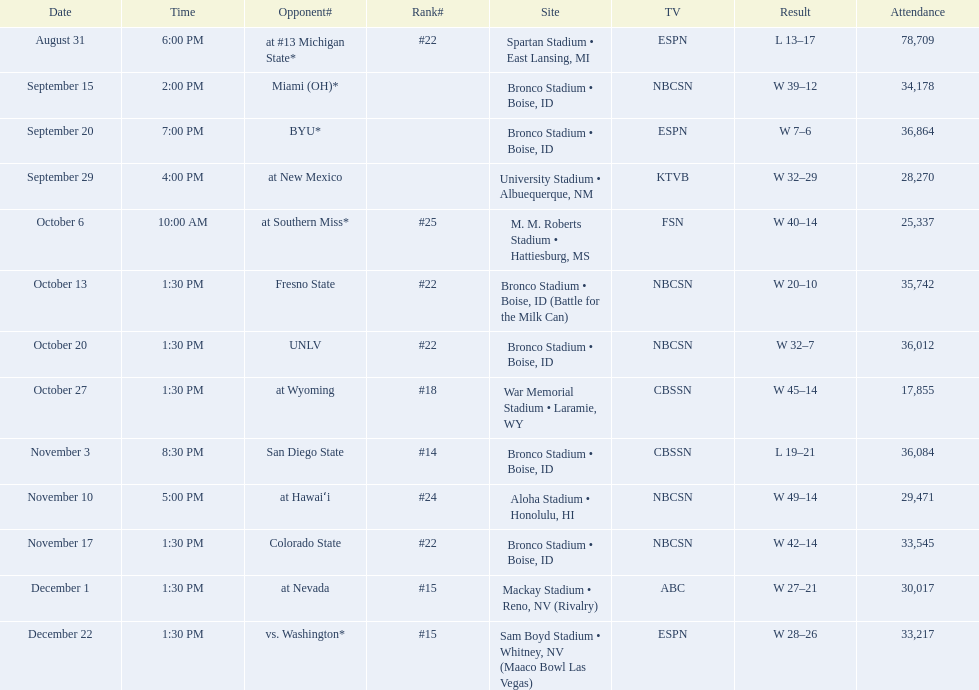Who were all the opponents for boise state? At #13 michigan state*, miami (oh)*, byu*, at new mexico, at southern miss*, fresno state, unlv, at wyoming, san diego state, at hawaiʻi, colorado state, at nevada, vs. washington*. Which opponents were ranked? At #13 michigan state*, #22, at southern miss*, #25, fresno state, #22, unlv, #22, at wyoming, #18, san diego state, #14. Which opponent had the highest rank? San Diego State. 